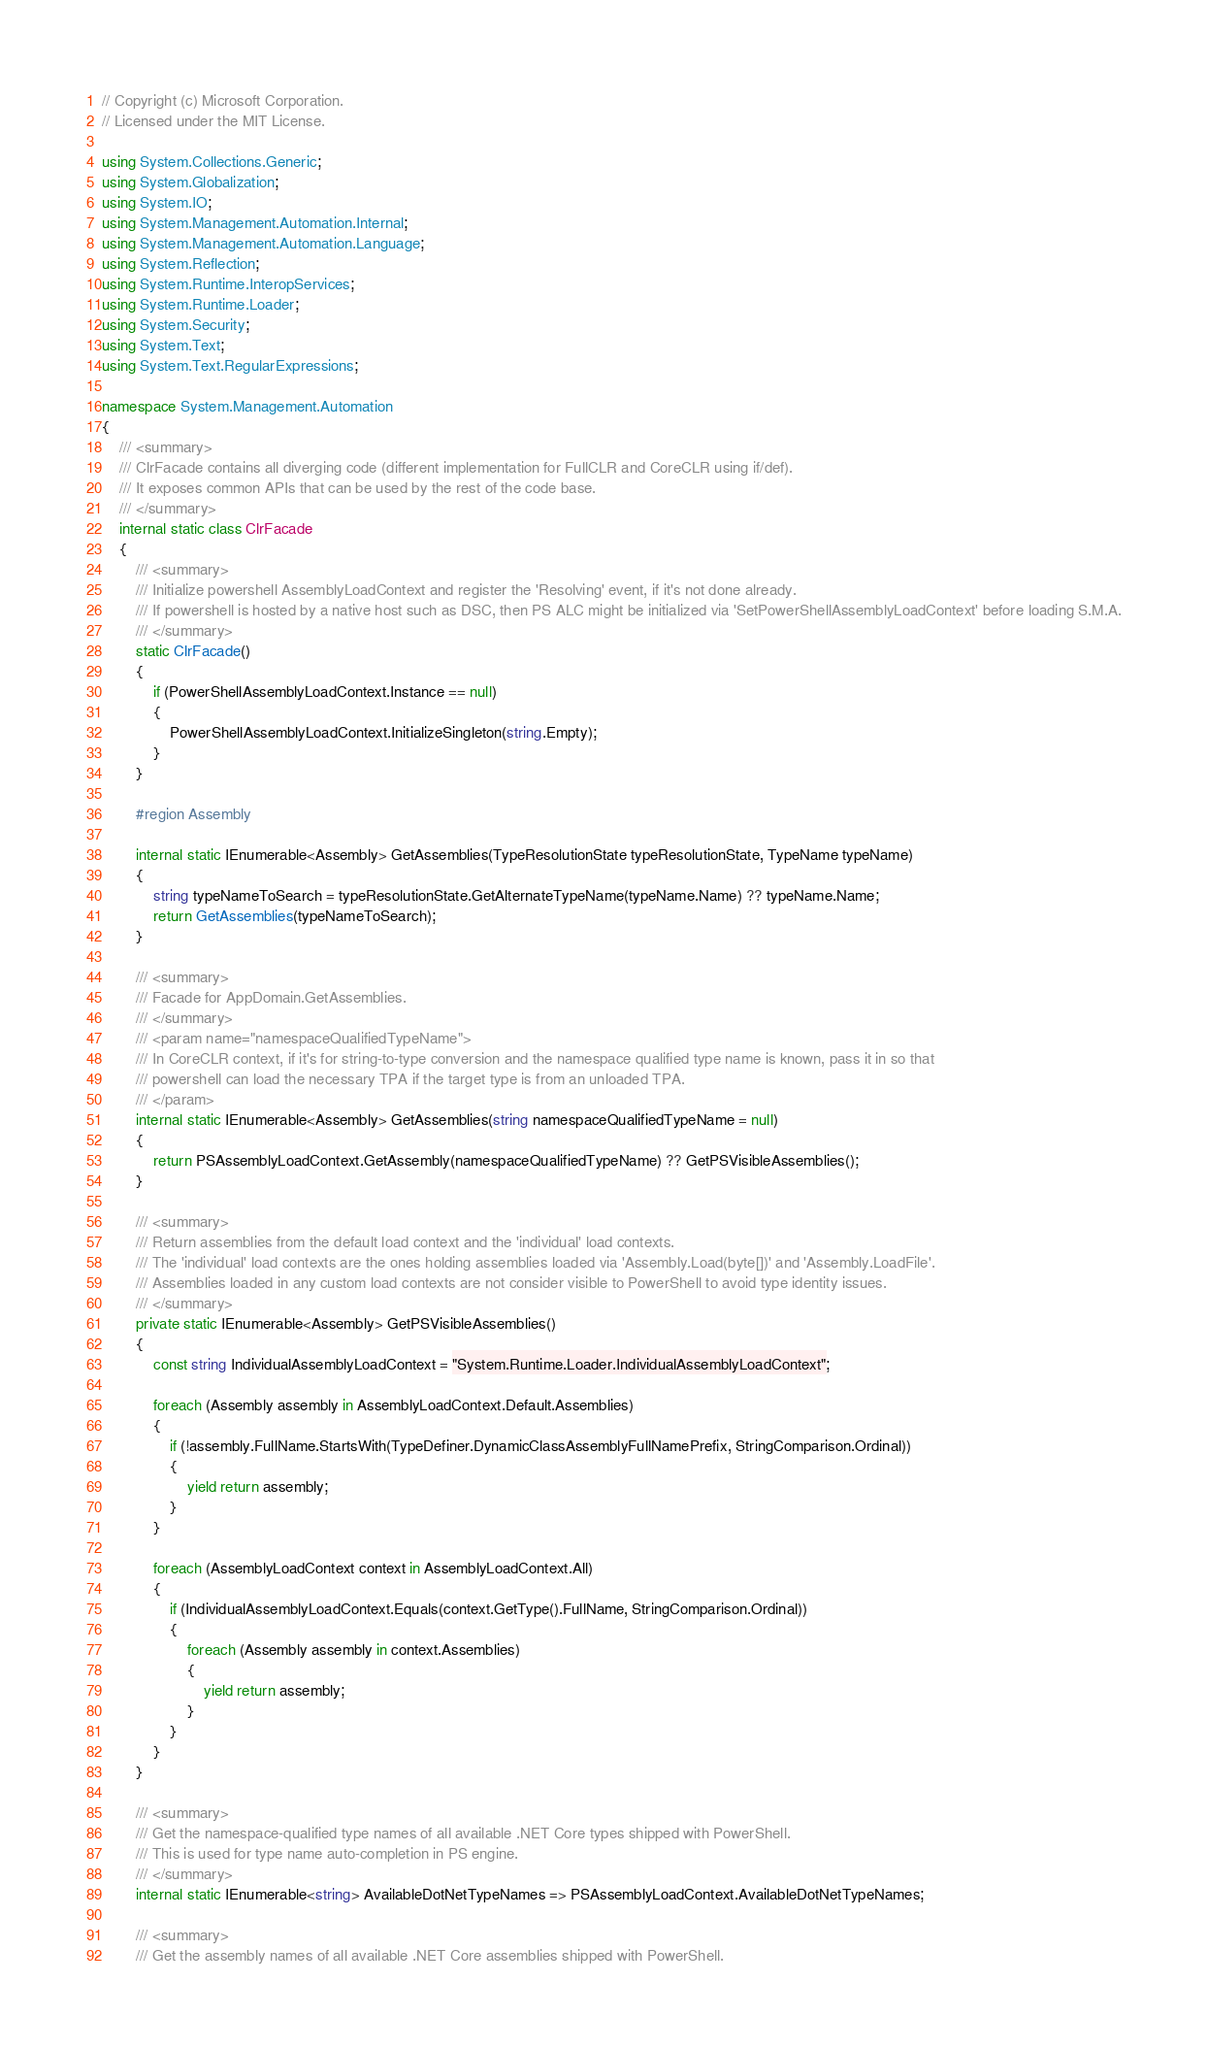Convert code to text. <code><loc_0><loc_0><loc_500><loc_500><_C#_>// Copyright (c) Microsoft Corporation.
// Licensed under the MIT License.

using System.Collections.Generic;
using System.Globalization;
using System.IO;
using System.Management.Automation.Internal;
using System.Management.Automation.Language;
using System.Reflection;
using System.Runtime.InteropServices;
using System.Runtime.Loader;
using System.Security;
using System.Text;
using System.Text.RegularExpressions;

namespace System.Management.Automation
{
    /// <summary>
    /// ClrFacade contains all diverging code (different implementation for FullCLR and CoreCLR using if/def).
    /// It exposes common APIs that can be used by the rest of the code base.
    /// </summary>
    internal static class ClrFacade
    {
        /// <summary>
        /// Initialize powershell AssemblyLoadContext and register the 'Resolving' event, if it's not done already.
        /// If powershell is hosted by a native host such as DSC, then PS ALC might be initialized via 'SetPowerShellAssemblyLoadContext' before loading S.M.A.
        /// </summary>
        static ClrFacade()
        {
            if (PowerShellAssemblyLoadContext.Instance == null)
            {
                PowerShellAssemblyLoadContext.InitializeSingleton(string.Empty);
            }
        }

        #region Assembly

        internal static IEnumerable<Assembly> GetAssemblies(TypeResolutionState typeResolutionState, TypeName typeName)
        {
            string typeNameToSearch = typeResolutionState.GetAlternateTypeName(typeName.Name) ?? typeName.Name;
            return GetAssemblies(typeNameToSearch);
        }

        /// <summary>
        /// Facade for AppDomain.GetAssemblies.
        /// </summary>
        /// <param name="namespaceQualifiedTypeName">
        /// In CoreCLR context, if it's for string-to-type conversion and the namespace qualified type name is known, pass it in so that
        /// powershell can load the necessary TPA if the target type is from an unloaded TPA.
        /// </param>
        internal static IEnumerable<Assembly> GetAssemblies(string namespaceQualifiedTypeName = null)
        {
            return PSAssemblyLoadContext.GetAssembly(namespaceQualifiedTypeName) ?? GetPSVisibleAssemblies();
        }

        /// <summary>
        /// Return assemblies from the default load context and the 'individual' load contexts.
        /// The 'individual' load contexts are the ones holding assemblies loaded via 'Assembly.Load(byte[])' and 'Assembly.LoadFile'.
        /// Assemblies loaded in any custom load contexts are not consider visible to PowerShell to avoid type identity issues.
        /// </summary>
        private static IEnumerable<Assembly> GetPSVisibleAssemblies()
        {
            const string IndividualAssemblyLoadContext = "System.Runtime.Loader.IndividualAssemblyLoadContext";

            foreach (Assembly assembly in AssemblyLoadContext.Default.Assemblies)
            {
                if (!assembly.FullName.StartsWith(TypeDefiner.DynamicClassAssemblyFullNamePrefix, StringComparison.Ordinal))
                {
                    yield return assembly;
                }
            }

            foreach (AssemblyLoadContext context in AssemblyLoadContext.All)
            {
                if (IndividualAssemblyLoadContext.Equals(context.GetType().FullName, StringComparison.Ordinal))
                {
                    foreach (Assembly assembly in context.Assemblies)
                    {
                        yield return assembly;
                    }
                }
            }
        }

        /// <summary>
        /// Get the namespace-qualified type names of all available .NET Core types shipped with PowerShell.
        /// This is used for type name auto-completion in PS engine.
        /// </summary>
        internal static IEnumerable<string> AvailableDotNetTypeNames => PSAssemblyLoadContext.AvailableDotNetTypeNames;

        /// <summary>
        /// Get the assembly names of all available .NET Core assemblies shipped with PowerShell.</code> 